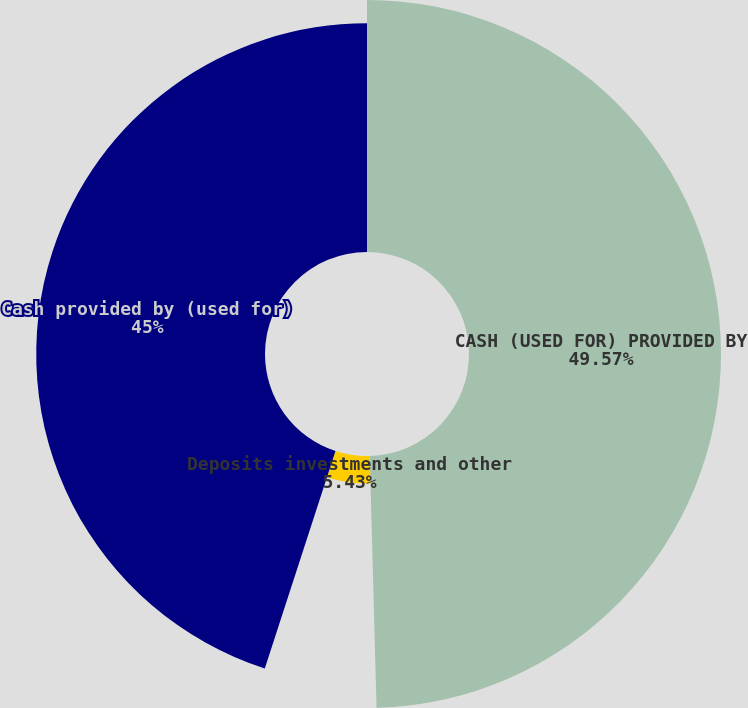Convert chart to OTSL. <chart><loc_0><loc_0><loc_500><loc_500><pie_chart><fcel>CASH (USED FOR) PROVIDED BY<fcel>Deposits investments and other<fcel>Cash provided by (used for)<nl><fcel>49.57%<fcel>5.43%<fcel>45.0%<nl></chart> 